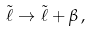<formula> <loc_0><loc_0><loc_500><loc_500>\tilde { \ell } \rightarrow \tilde { \ell } + \beta \, ,</formula> 